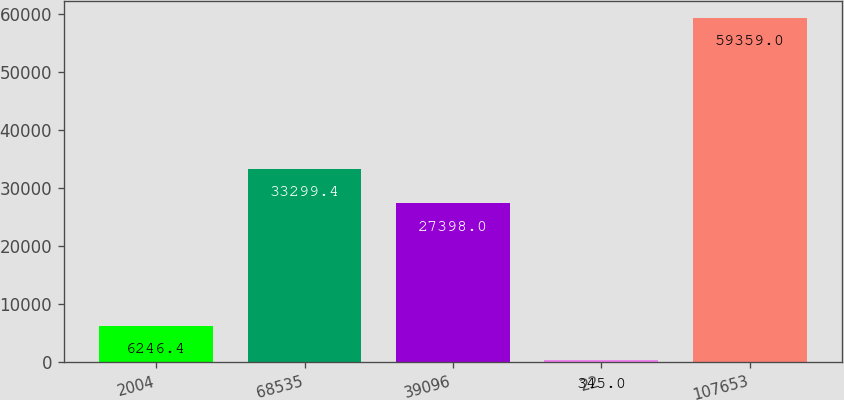Convert chart to OTSL. <chart><loc_0><loc_0><loc_500><loc_500><bar_chart><fcel>2004<fcel>68535<fcel>39096<fcel>22<fcel>107653<nl><fcel>6246.4<fcel>33299.4<fcel>27398<fcel>345<fcel>59359<nl></chart> 